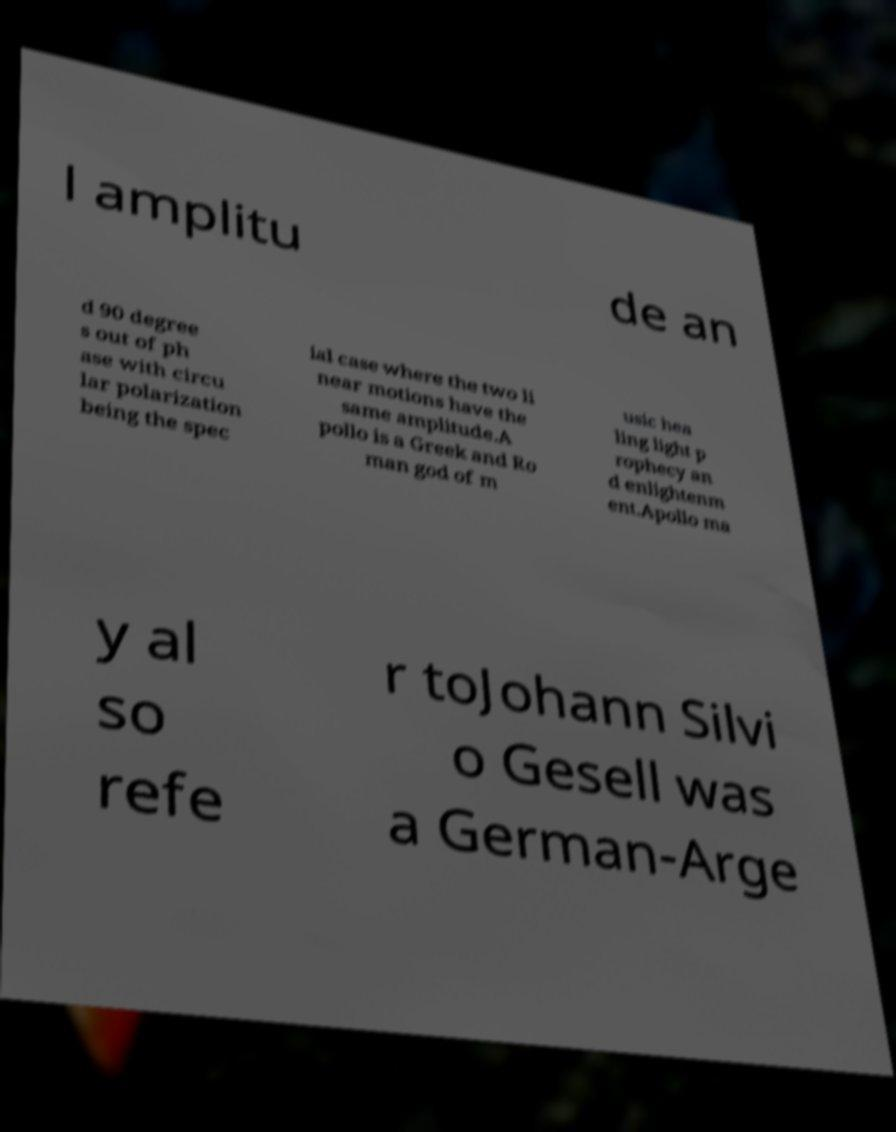There's text embedded in this image that I need extracted. Can you transcribe it verbatim? l amplitu de an d 90 degree s out of ph ase with circu lar polarization being the spec ial case where the two li near motions have the same amplitude.A pollo is a Greek and Ro man god of m usic hea ling light p rophecy an d enlightenm ent.Apollo ma y al so refe r toJohann Silvi o Gesell was a German-Arge 